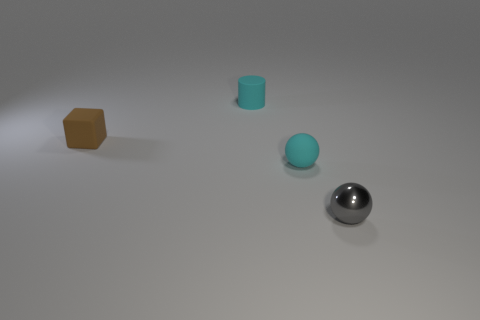Add 4 tiny spheres. How many objects exist? 8 Subtract all cylinders. How many objects are left? 3 Subtract 1 brown cubes. How many objects are left? 3 Subtract all small cyan rubber things. Subtract all cyan matte objects. How many objects are left? 0 Add 4 cyan things. How many cyan things are left? 6 Add 1 cylinders. How many cylinders exist? 2 